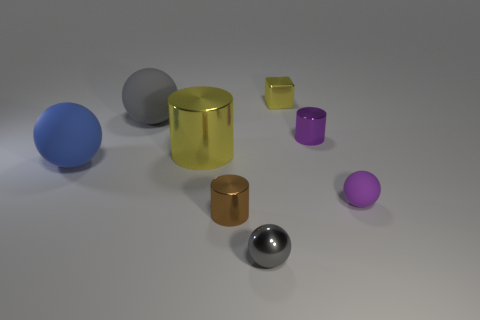Subtract all tiny gray balls. How many balls are left? 3 Subtract all blue cubes. How many gray spheres are left? 2 Add 2 tiny brown metal cylinders. How many objects exist? 10 Subtract all yellow cylinders. How many cylinders are left? 2 Subtract 2 cylinders. How many cylinders are left? 1 Subtract 1 purple cylinders. How many objects are left? 7 Subtract all cubes. How many objects are left? 7 Subtract all green cubes. Subtract all brown balls. How many cubes are left? 1 Subtract all tiny blue spheres. Subtract all tiny brown shiny cylinders. How many objects are left? 7 Add 5 brown things. How many brown things are left? 6 